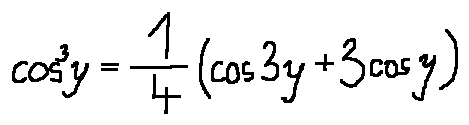Convert formula to latex. <formula><loc_0><loc_0><loc_500><loc_500>\cos ^ { 3 } y = \frac { 1 } { 4 } ( \cos 3 y + 3 \cos y )</formula> 